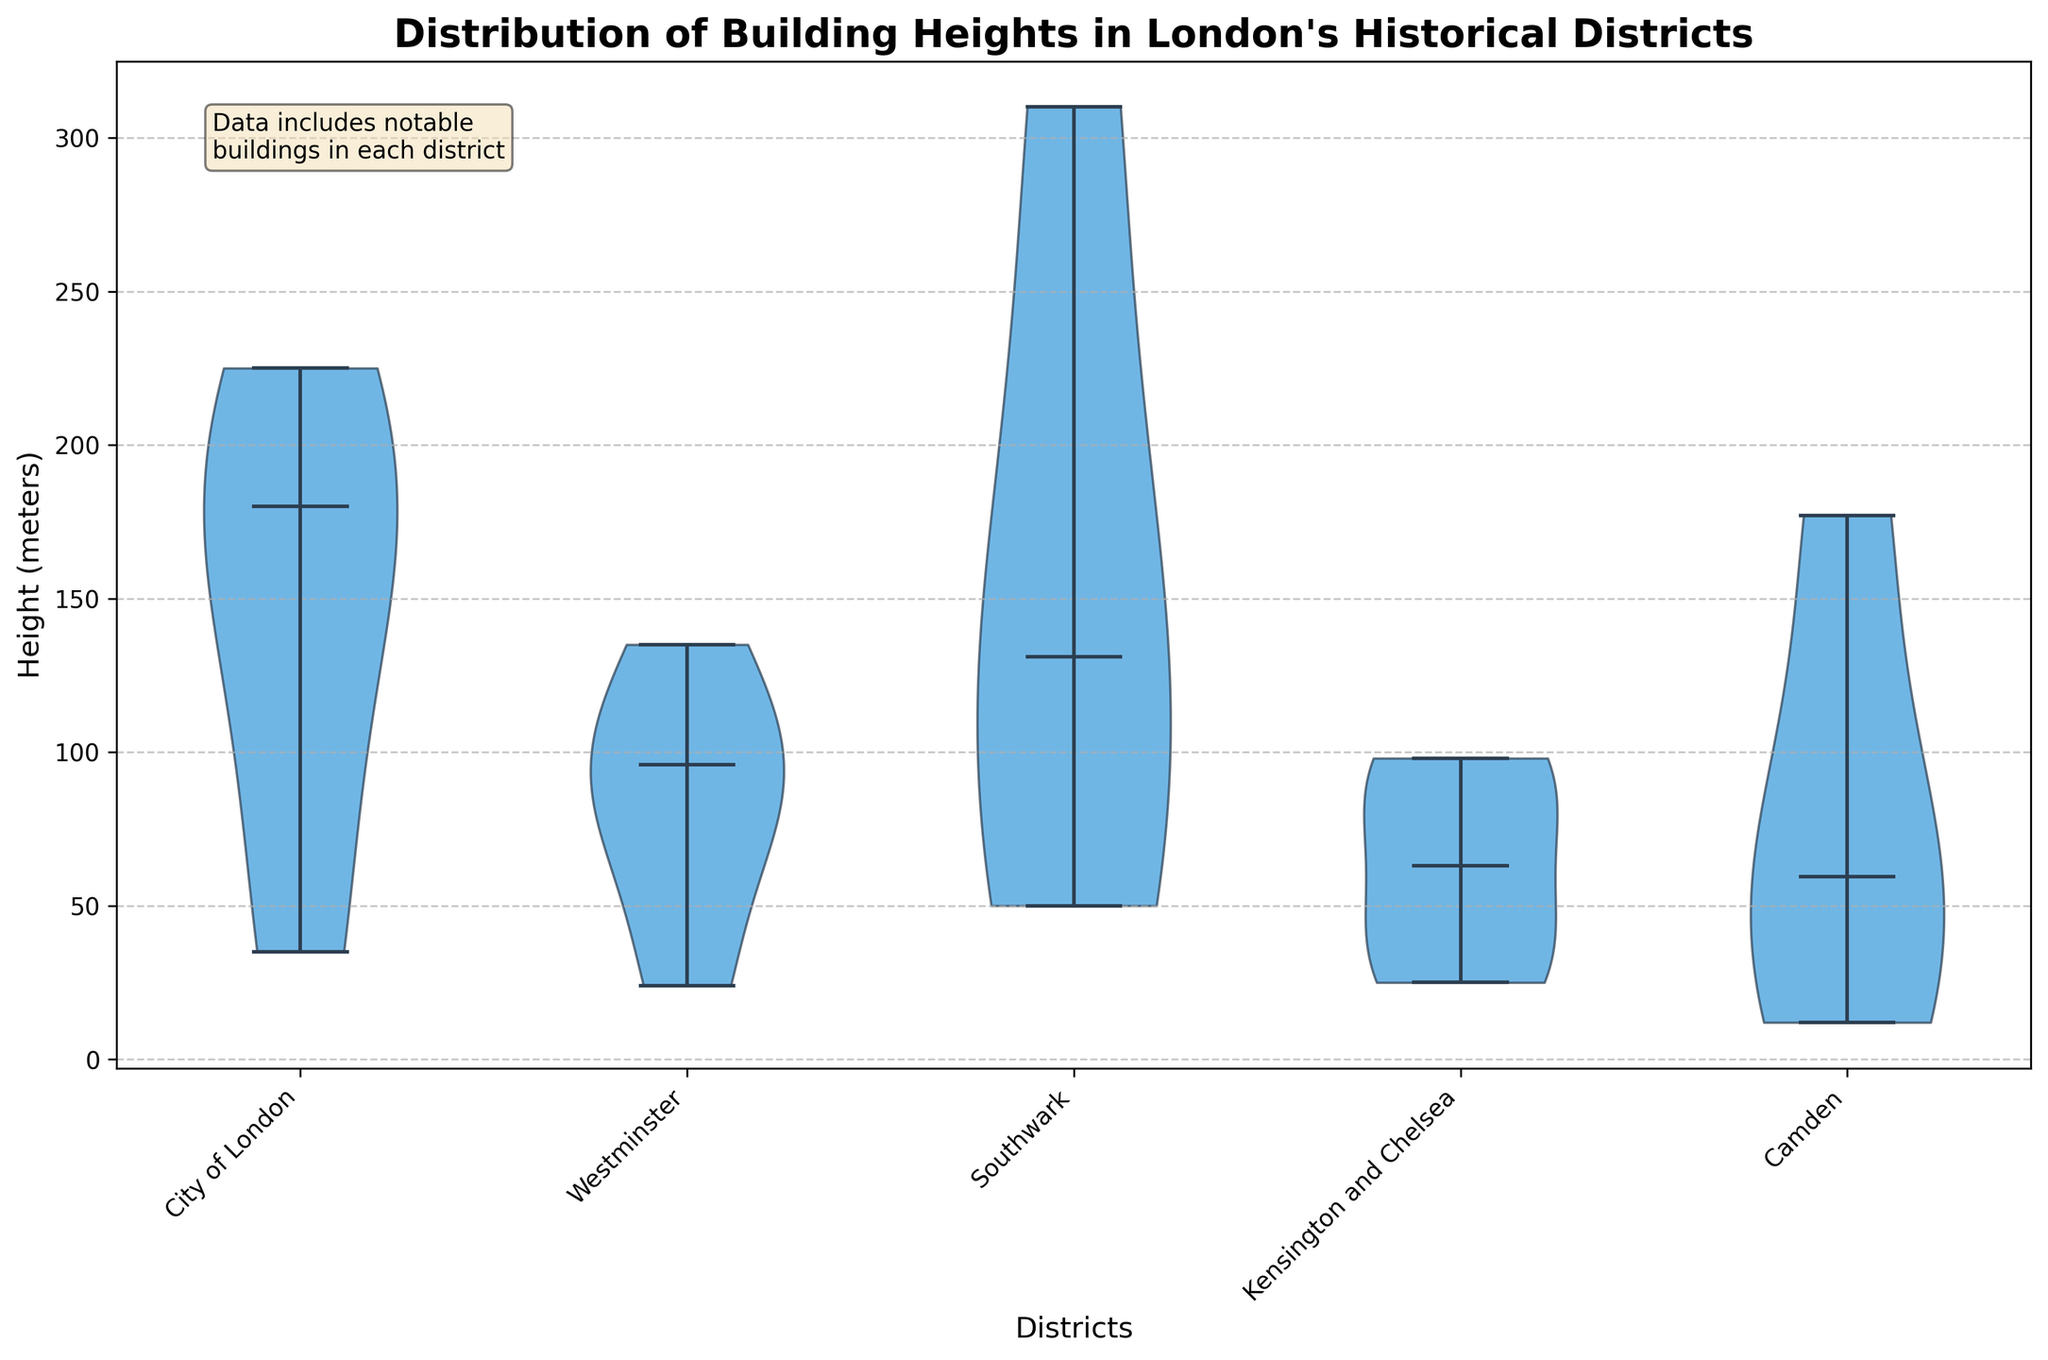What is the height scale used in this violin plot? The y-axis in the violin plot is labeled and scaled with height in meters. By looking at the axis labels, you can see the heights represented.
Answer: meters Which district has the highest maximum building height? By observing the violin plot, you can see that Southwark has the tallest building peaking around the 310 meters mark, which is The Shard.
Answer: Southwark How many districts are shown in the violin plot? The x-axis shows the different districts represented. Counting the number of district names labeled on the x-axis, we find there are five districts.
Answer: Five Which district has the smallest spread in building heights? To determine the smallest spread, look at the width and range of the violins. The narrowest and least variable one is for Camden.
Answer: Camden What is the median height of buildings in the City of London? The dashed line within the violin for the City of London represents the median. In this case, it aligns around the 180 meters mark.
Answer: 180 meters Compare the median building heights of Westminster and Camden. Which one is higher? Look at the median lines in the violins for Westminster and Camden. The line in Westminster is higher than the one in Camden, indicating that the median height in Westminster is higher.
Answer: Westminster What can you infer about the distribution of building heights in Kensington and Chelsea? The violin for Kensington and Chelsea is relatively narrow with a slight bell shape, indicating that most buildings are clustered around a similar height, specifically in the lower to mid-range.
Answer: Clustered around lower to mid-range heights Which district has the tallest building in London? By examining each violin plot, you determine the highest peak. Southwark's violin extends to the highest point, indicating it has the tallest building: The Shard at 310 meters.
Answer: Southwark Does the violin plot show any outliers in the building heights? Outliers would be depicted as distinct dots or lines far from the main body of the violin. The plot does not explicitly show individual dots that would represent outliers.
Answer: No Which district has the widest range of building heights? To find the widest range, look for the violin that spans the greatest vertical length. The City of London's violin, spanning from about 35 to 225 meters, has a wide range of building heights.
Answer: City of London 